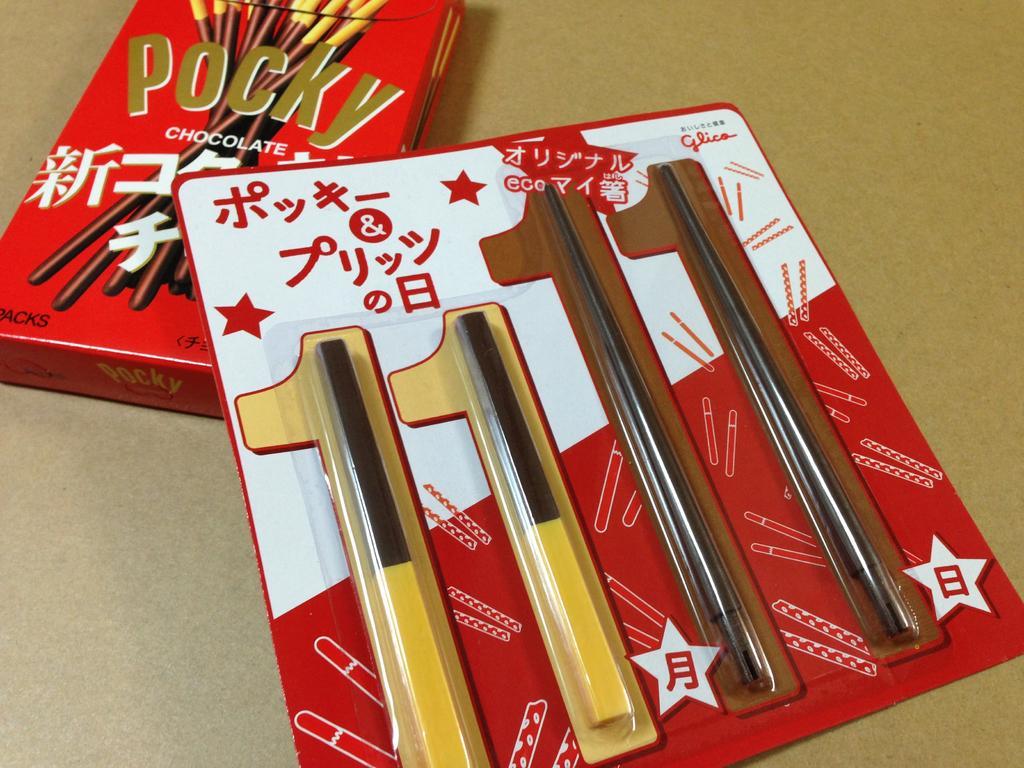Could you give a brief overview of what you see in this image? In this picture we can see a packet and a box on the surface. 